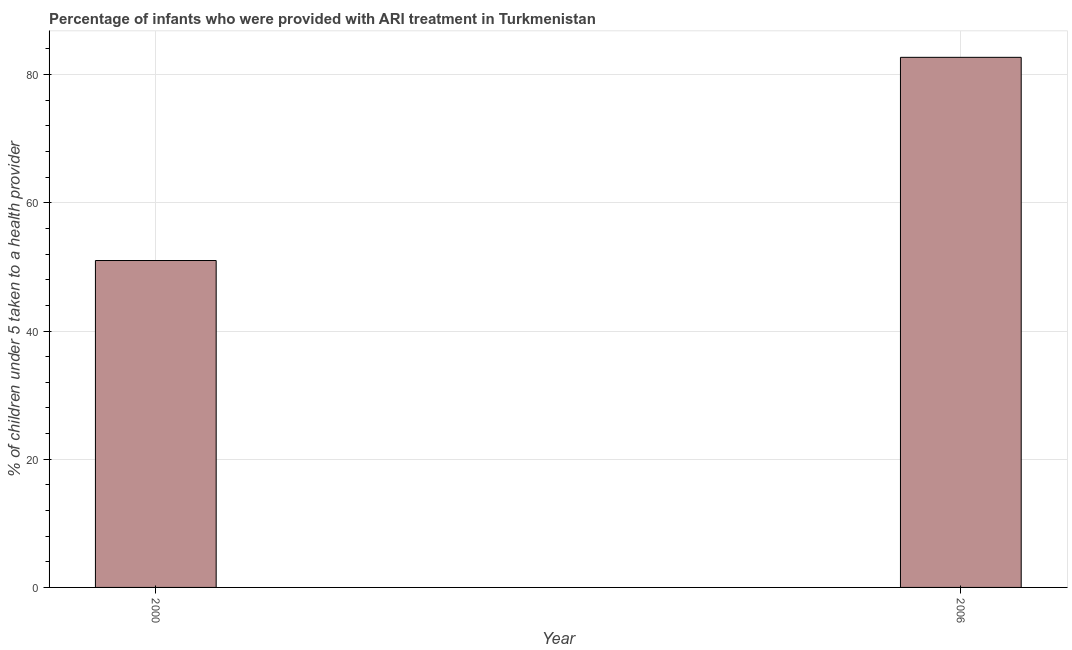Does the graph contain grids?
Make the answer very short. Yes. What is the title of the graph?
Offer a terse response. Percentage of infants who were provided with ARI treatment in Turkmenistan. What is the label or title of the X-axis?
Your response must be concise. Year. What is the label or title of the Y-axis?
Provide a short and direct response. % of children under 5 taken to a health provider. What is the percentage of children who were provided with ari treatment in 2006?
Ensure brevity in your answer.  82.7. Across all years, what is the maximum percentage of children who were provided with ari treatment?
Keep it short and to the point. 82.7. In which year was the percentage of children who were provided with ari treatment maximum?
Make the answer very short. 2006. In which year was the percentage of children who were provided with ari treatment minimum?
Your answer should be compact. 2000. What is the sum of the percentage of children who were provided with ari treatment?
Your response must be concise. 133.7. What is the difference between the percentage of children who were provided with ari treatment in 2000 and 2006?
Your response must be concise. -31.7. What is the average percentage of children who were provided with ari treatment per year?
Your answer should be very brief. 66.85. What is the median percentage of children who were provided with ari treatment?
Ensure brevity in your answer.  66.85. In how many years, is the percentage of children who were provided with ari treatment greater than 60 %?
Ensure brevity in your answer.  1. What is the ratio of the percentage of children who were provided with ari treatment in 2000 to that in 2006?
Offer a terse response. 0.62. How many bars are there?
Your answer should be compact. 2. What is the difference between two consecutive major ticks on the Y-axis?
Give a very brief answer. 20. Are the values on the major ticks of Y-axis written in scientific E-notation?
Your answer should be compact. No. What is the % of children under 5 taken to a health provider in 2006?
Provide a short and direct response. 82.7. What is the difference between the % of children under 5 taken to a health provider in 2000 and 2006?
Provide a succinct answer. -31.7. What is the ratio of the % of children under 5 taken to a health provider in 2000 to that in 2006?
Give a very brief answer. 0.62. 